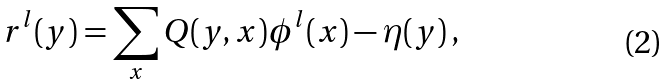<formula> <loc_0><loc_0><loc_500><loc_500>r ^ { l } ( y ) = \sum _ { x } Q ( y , x ) \phi ^ { l } ( x ) - \eta ( y ) \, ,</formula> 